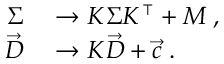Convert formula to latex. <formula><loc_0><loc_0><loc_500><loc_500>\begin{array} { r l } { \Sigma } & \rightarrow K \Sigma K ^ { \intercal } + M \, , } \\ { \vec { D } } & \rightarrow K \vec { D } + \vec { c } \, . } \end{array}</formula> 